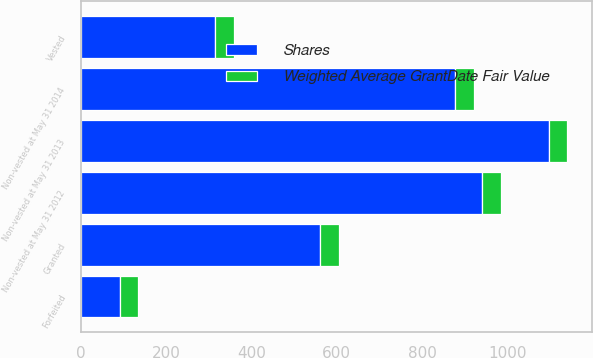Convert chart to OTSL. <chart><loc_0><loc_0><loc_500><loc_500><stacked_bar_chart><ecel><fcel>Non-vested at May 31 2012<fcel>Granted<fcel>Vested<fcel>Forfeited<fcel>Non-vested at May 31 2013<fcel>Non-vested at May 31 2014<nl><fcel>Shares<fcel>941<fcel>561<fcel>315<fcel>91<fcel>1096<fcel>877<nl><fcel>Weighted Average GrantDate Fair Value<fcel>44<fcel>44<fcel>43<fcel>44<fcel>44<fcel>45<nl></chart> 